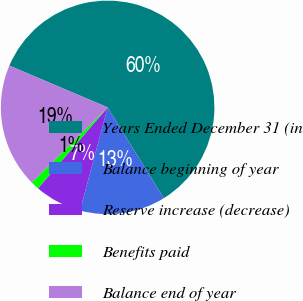<chart> <loc_0><loc_0><loc_500><loc_500><pie_chart><fcel>Years Ended December 31 (in<fcel>Balance beginning of year<fcel>Reserve increase (decrease)<fcel>Benefits paid<fcel>Balance end of year<nl><fcel>59.79%<fcel>12.98%<fcel>7.13%<fcel>1.27%<fcel>18.83%<nl></chart> 